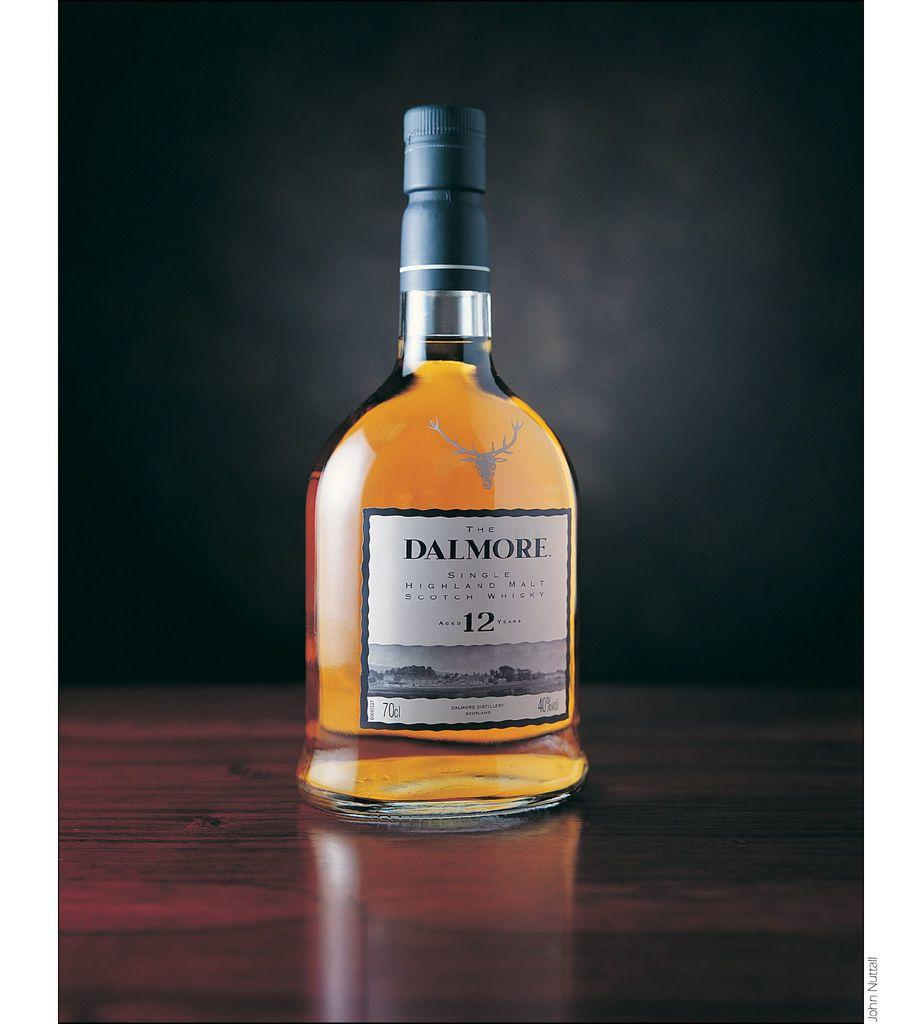<image>
Share a concise interpretation of the image provided. A bottle of Dalmore single highland malt scotch whiskey on a wood surface. 